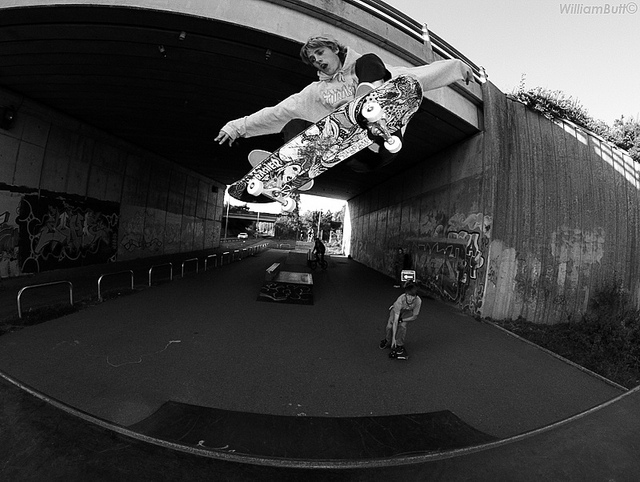Please transcribe the text in this image. William Butt 